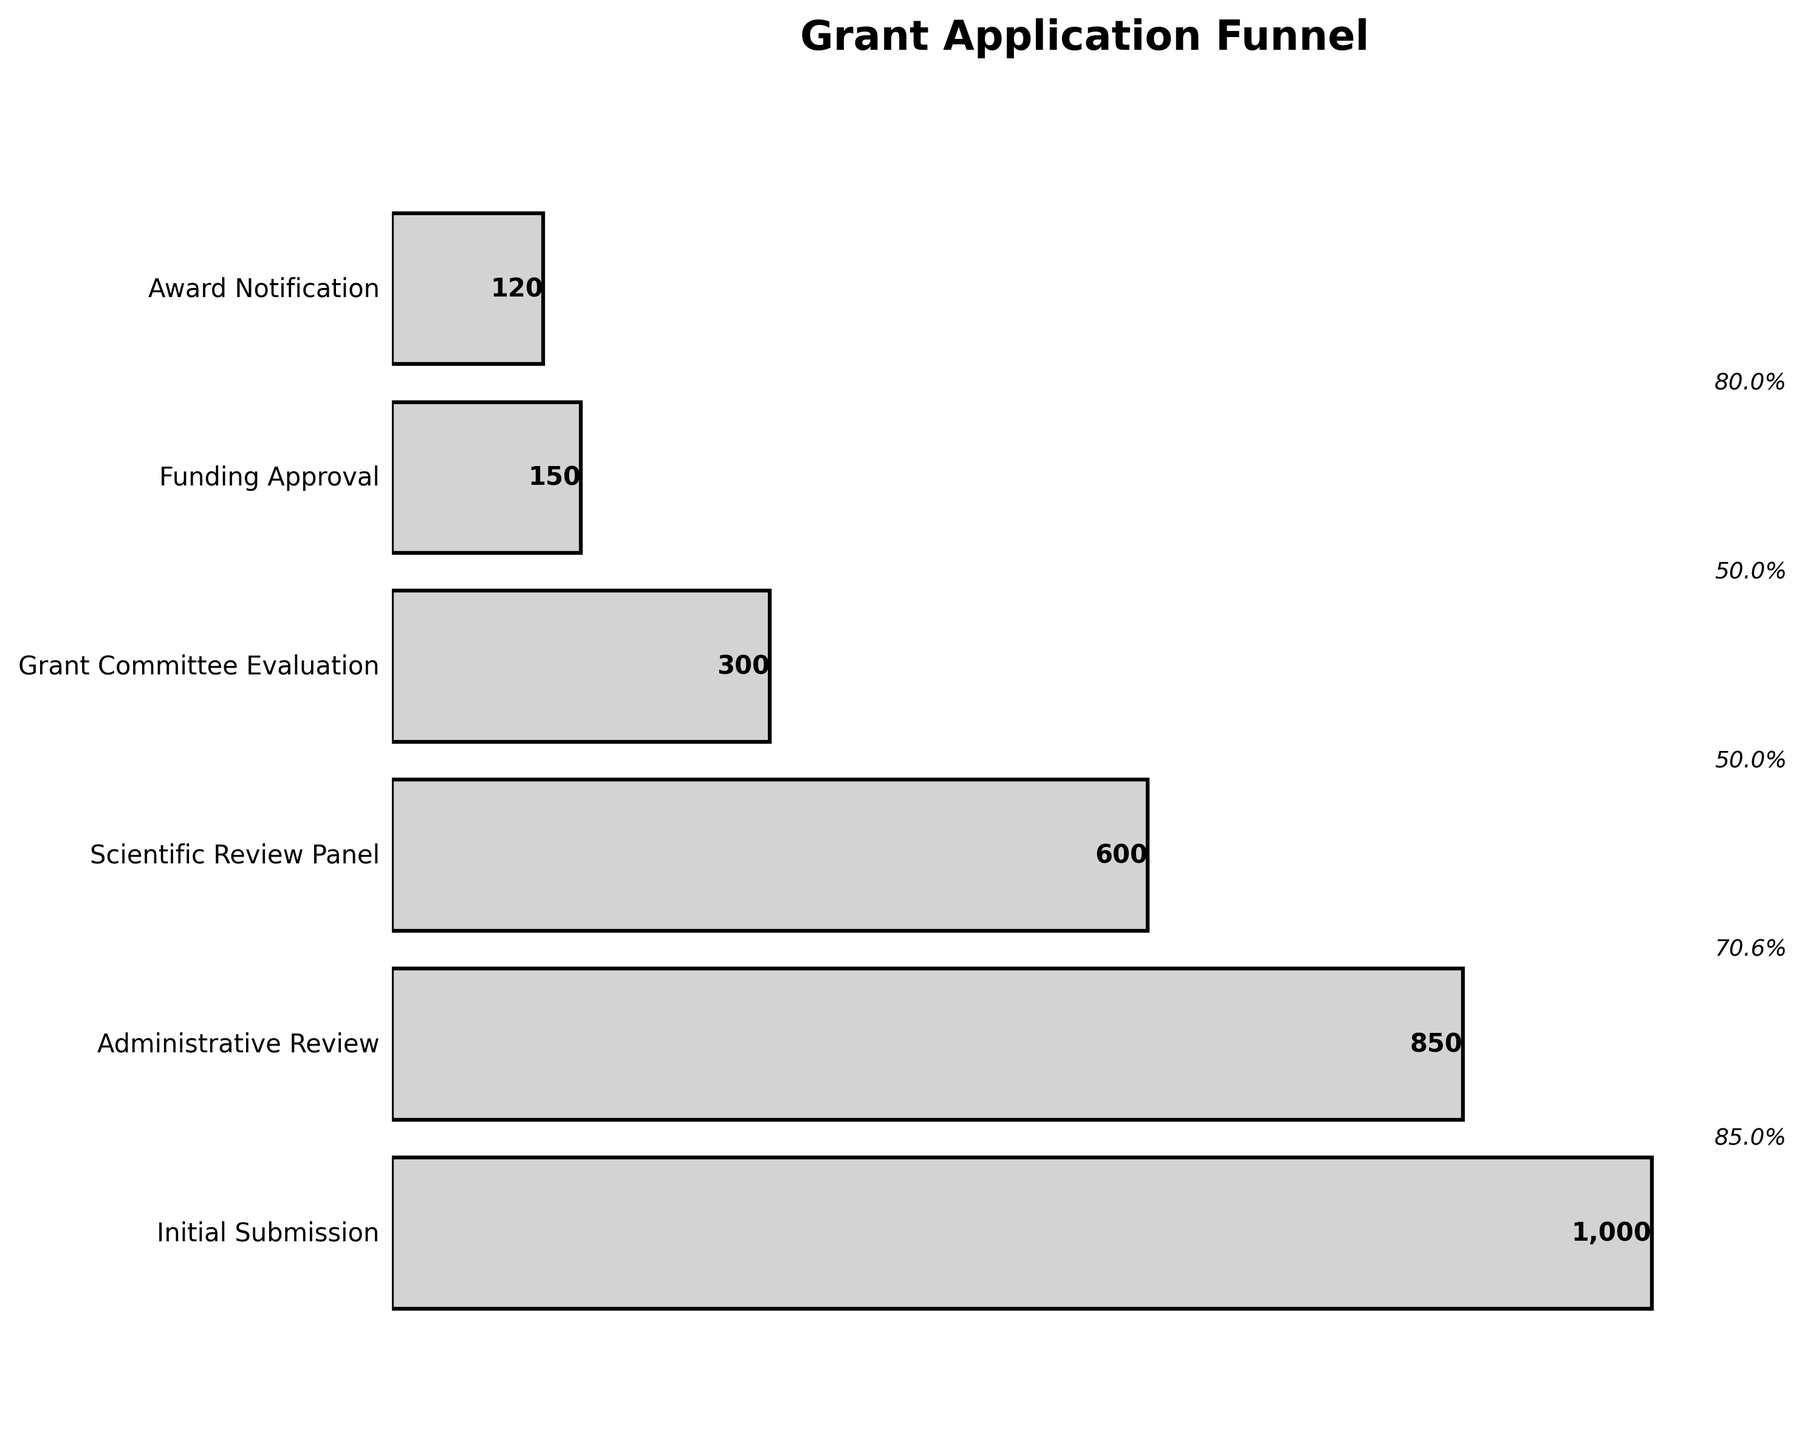what is the title of the plot? The title of the plot is usually located at the top center of the figure. In this plot, the title is clearly visible above the graphical elements.
Answer: Grant Application Funnel How many stages are there in the funnel chart? By counting the horizontal bars representing each stage, we can see that there are six stages.
Answer: Six Which stage has the highest number of applications? The stage with the widest bar (or the largest numerical value) is "Initial Submission," which has 1,000 applications.
Answer: Initial Submission What is the number of applications at the Award Notification stage? The text label next to the bar for the "Award Notification" stage shows 120 applications in bold font.
Answer: 120 By what percentage do applications decrease from the Scientific Review Panel to the Grant Committee Evaluation? First, identify the number of applications at each stage: 600 at the Scientific Review Panel and 300 at the Grant Committee Evaluation. Calculate the percentage decrease as (300/600) * 100%, which equals 50%.
Answer: 50% What is the difference in the number of applications between the Administrative Review and the Funding Approval stages? The number of applications at the Administrative Review stage is 850, and at the Funding Approval stage, it is 150. The difference is 850 - 150 = 700 applications.
Answer: 700 Which stage shows the largest percentage drop in applications compared to the previous stage? By examining the percentage labels between bars, the stage from "Grant Committee Evaluation" to "Funding Approval" shows the largest drop, which is 50%. This can be calculated by (150/300) * 100% = 50%.
Answer: Funding Approval What percentage of the initial submissions reaches the Scientific Review Panel stage? Start with the initial number of applications (1,000) and the number that reaches the Scientific Review Panel (600). Calculate the percentage as (600/1000) * 100% = 60%.
Answer: 60% How many applications are filtered out during the Grant Committee Evaluation stage? The number of applications decreases from 600 at the Scientific Review Panel stage to 300 at the Grant Committee Evaluation stage. The difference is 600 - 300 = 300 filtered applications.
Answer: 300 What is the average number of applications across all stages? Sum the number of applications in all stages (1000 + 850 + 600 + 300 + 150 + 120 = 3020). Divide by the number of stages (6) to find the average: 3020 / 6 = 503.33.
Answer: 503.33 